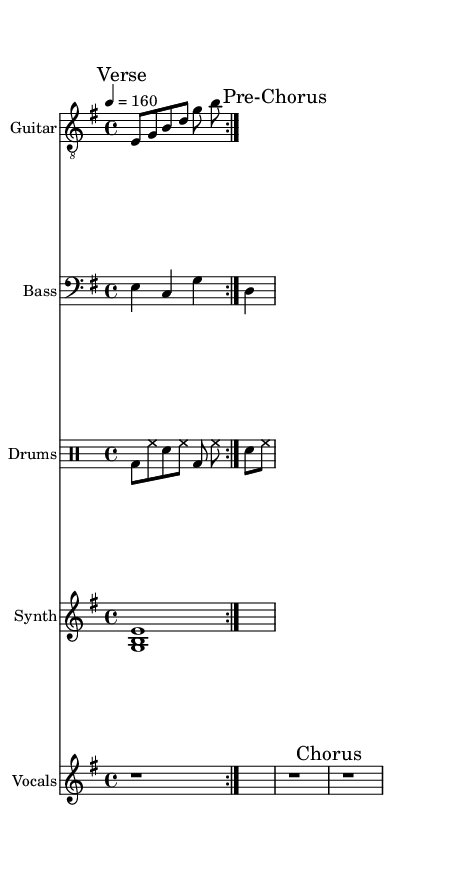What is the key signature of this music? The key signature is indicated by the key signature at the beginning of the sheet music. It shows two sharps, which corresponds to E minor.
Answer: E minor What is the time signature of this music? The time signature can be found at the beginning of the staff and indicates how many beats are in each measure. In this case, it shows 4/4 time.
Answer: 4/4 What is the tempo marking of this music? The tempo marking is noted in the sheet music and indicates the speed of the piece. Here it states "4 = 160". This means there are 160 beats per minute.
Answer: 160 What instruments are featured in this score? The instruments are listed in the staff headers. The sheet music includes Guitar, Bass, Drums, Synth, and Vocals, as specified in the headers of each staff.
Answer: Guitar, Bass, Drums, Synth, Vocals How many times is the guitar riff repeated? The repeat indication "volta 2" shows that the guitar riff is meant to be played twice in succession.
Answer: 2 What note does the synth play? The synth staff shows the note being played in the measure. It is indicated as an E major chord, consisting of the notes E, G, and B played together for a whole note.
Answer: E, G, B What is the role of the vocals in this piece? The vocals in this score are marked with sections such as "Verse", "Pre-Chorus", and "Chorus", indicating its structural role throughout the composition. In this case, they are represented as rests for each section, suggesting an instrumental focus in this instance.
Answer: Rests 